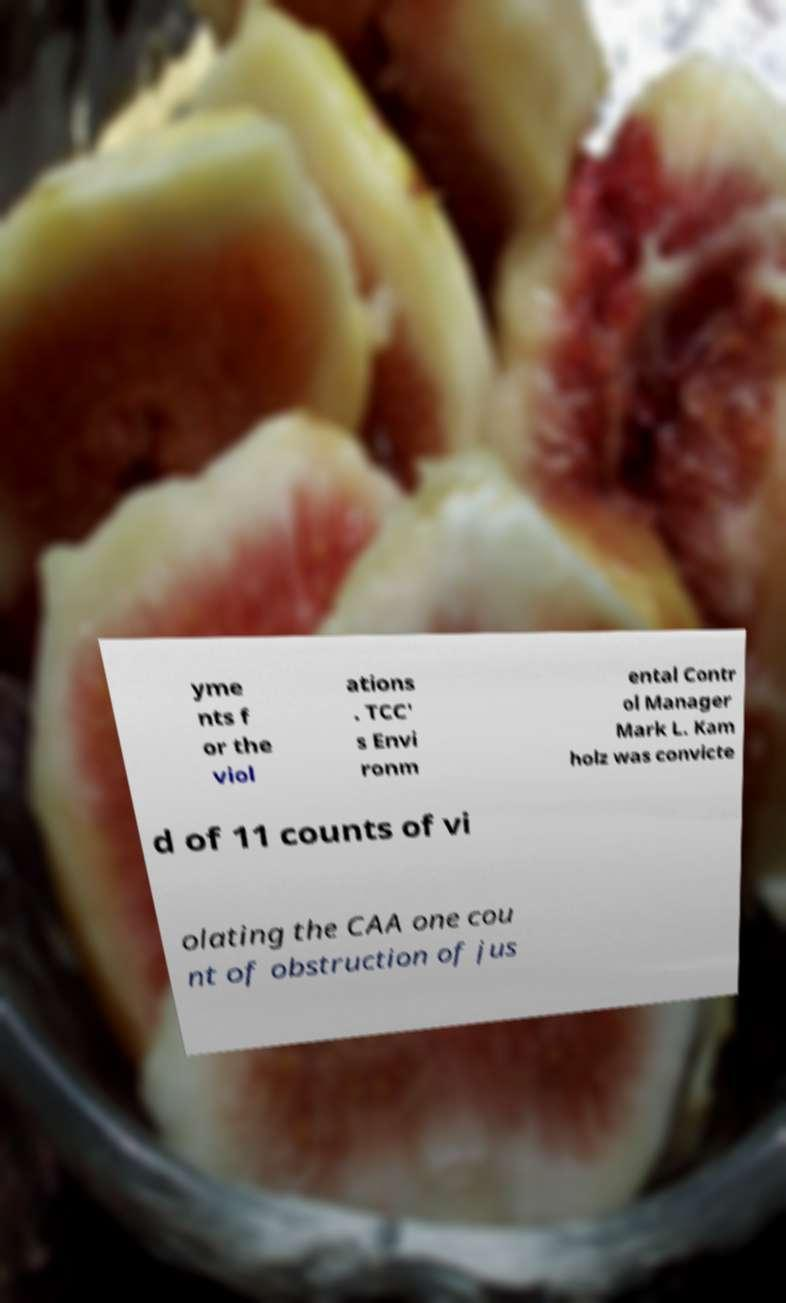Please identify and transcribe the text found in this image. yme nts f or the viol ations . TCC' s Envi ronm ental Contr ol Manager Mark L. Kam holz was convicte d of 11 counts of vi olating the CAA one cou nt of obstruction of jus 